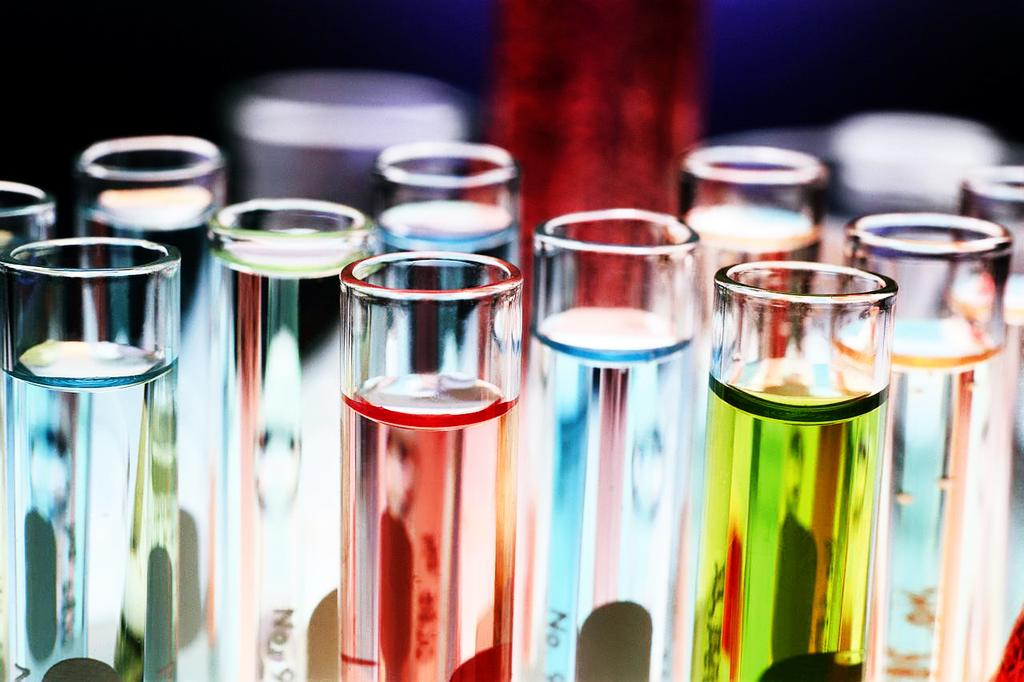<image>
Relay a brief, clear account of the picture shown. Multiple different colour liquids in test tubes with NO written on them. 